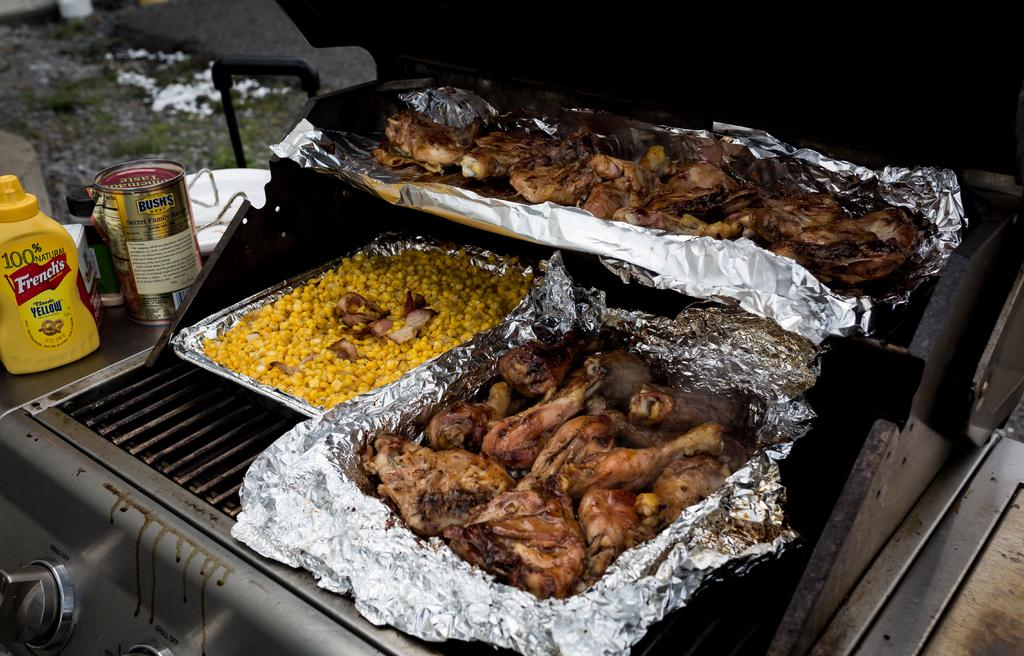<image>
Offer a succinct explanation of the picture presented. barbecue chicken and corn on a grill with French's mustard on the grill sideboard 